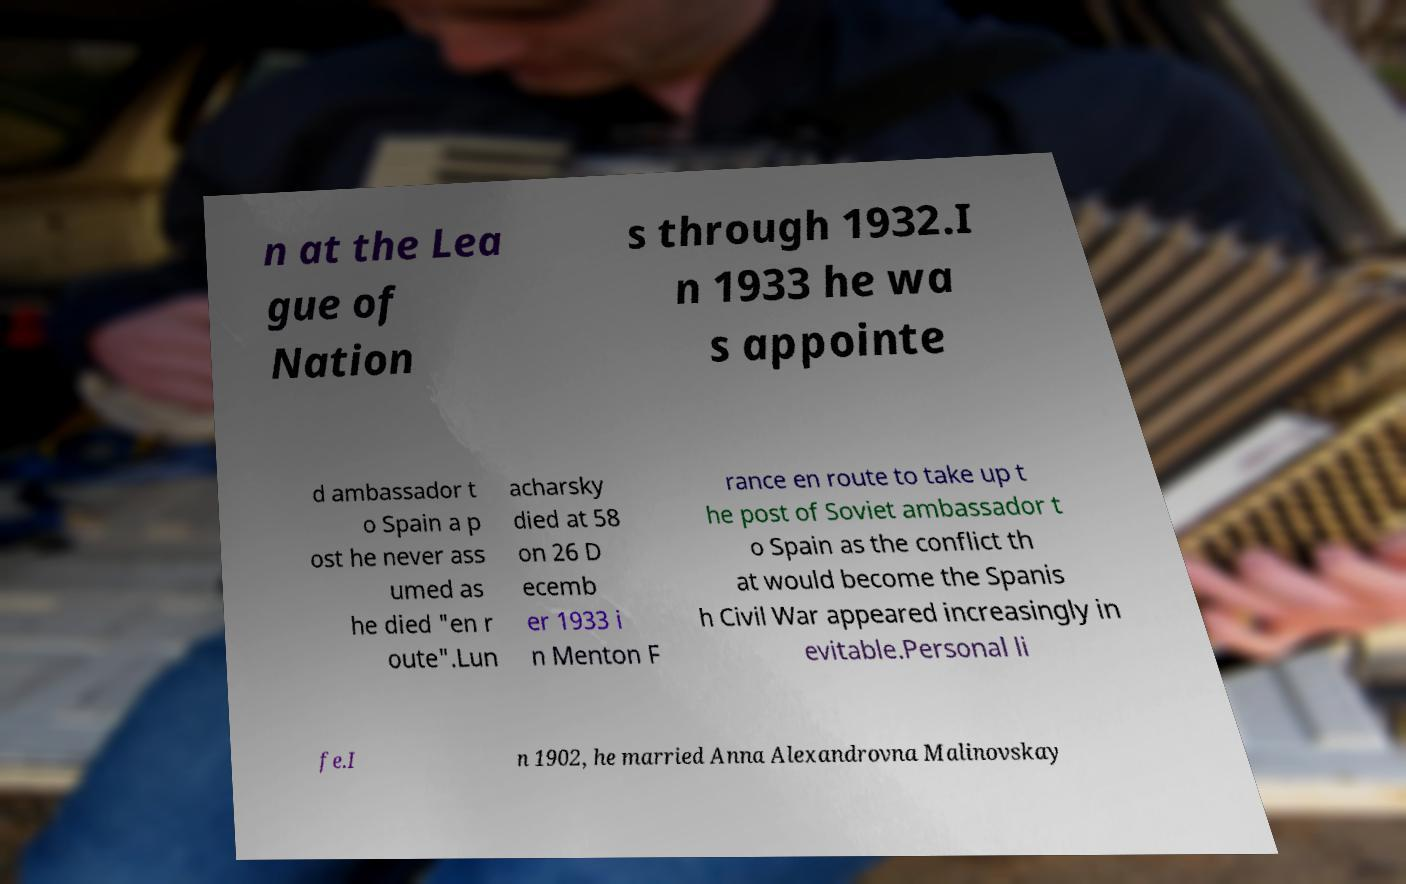Please read and relay the text visible in this image. What does it say? n at the Lea gue of Nation s through 1932.I n 1933 he wa s appointe d ambassador t o Spain a p ost he never ass umed as he died "en r oute".Lun acharsky died at 58 on 26 D ecemb er 1933 i n Menton F rance en route to take up t he post of Soviet ambassador t o Spain as the conflict th at would become the Spanis h Civil War appeared increasingly in evitable.Personal li fe.I n 1902, he married Anna Alexandrovna Malinovskay 